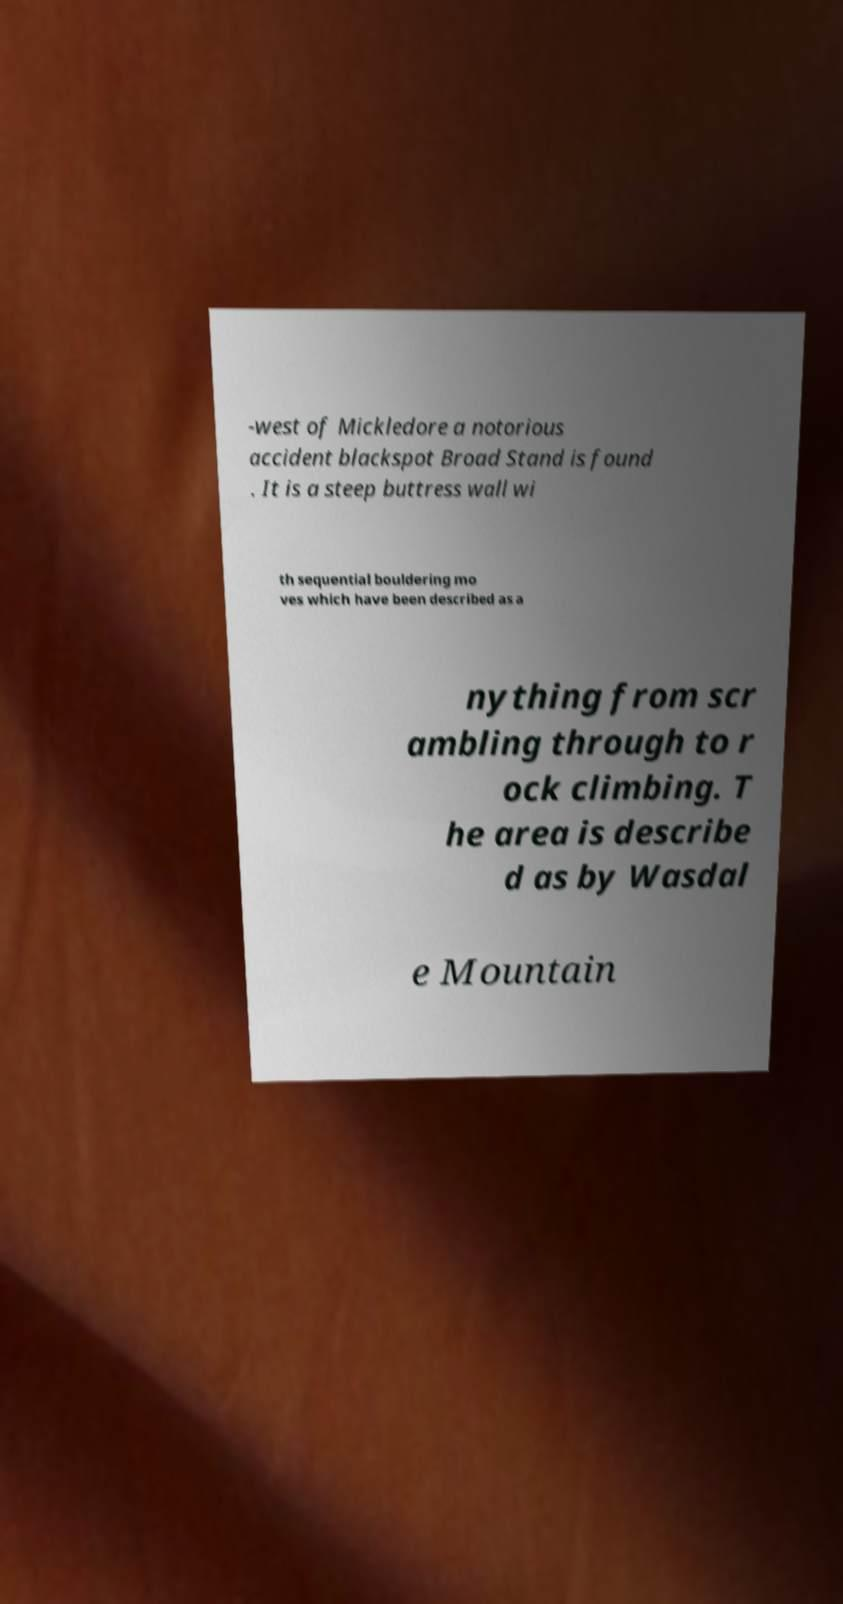For documentation purposes, I need the text within this image transcribed. Could you provide that? -west of Mickledore a notorious accident blackspot Broad Stand is found . It is a steep buttress wall wi th sequential bouldering mo ves which have been described as a nything from scr ambling through to r ock climbing. T he area is describe d as by Wasdal e Mountain 